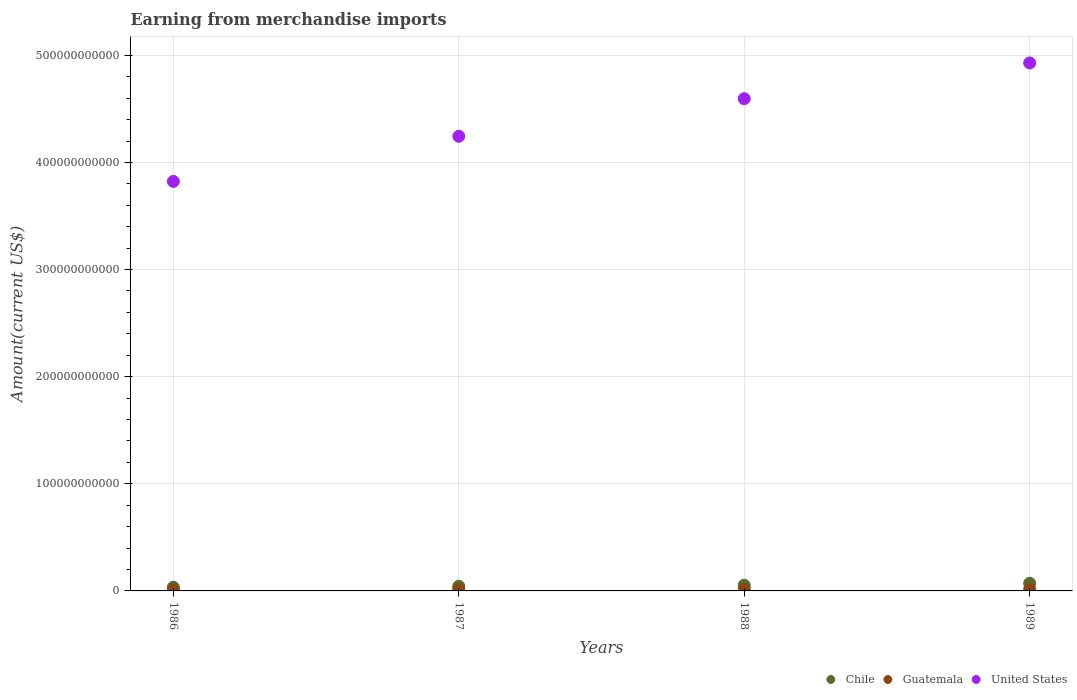How many different coloured dotlines are there?
Your answer should be compact. 3. What is the amount earned from merchandise imports in United States in 1986?
Ensure brevity in your answer.  3.82e+11. Across all years, what is the maximum amount earned from merchandise imports in Chile?
Ensure brevity in your answer.  7.14e+09. Across all years, what is the minimum amount earned from merchandise imports in Chile?
Offer a terse response. 3.44e+09. What is the total amount earned from merchandise imports in Chile in the graph?
Your answer should be compact. 2.03e+1. What is the difference between the amount earned from merchandise imports in Chile in 1986 and that in 1988?
Give a very brief answer. -1.86e+09. What is the difference between the amount earned from merchandise imports in Guatemala in 1986 and the amount earned from merchandise imports in United States in 1987?
Offer a very short reply. -4.23e+11. What is the average amount earned from merchandise imports in Chile per year?
Your answer should be compact. 5.07e+09. In the year 1986, what is the difference between the amount earned from merchandise imports in Chile and amount earned from merchandise imports in United States?
Make the answer very short. -3.79e+11. In how many years, is the amount earned from merchandise imports in Guatemala greater than 260000000000 US$?
Ensure brevity in your answer.  0. What is the ratio of the amount earned from merchandise imports in Guatemala in 1986 to that in 1989?
Make the answer very short. 0.58. Is the amount earned from merchandise imports in Guatemala in 1986 less than that in 1988?
Make the answer very short. Yes. Is the difference between the amount earned from merchandise imports in Chile in 1988 and 1989 greater than the difference between the amount earned from merchandise imports in United States in 1988 and 1989?
Your answer should be compact. Yes. What is the difference between the highest and the second highest amount earned from merchandise imports in Chile?
Your answer should be very brief. 1.85e+09. What is the difference between the highest and the lowest amount earned from merchandise imports in Chile?
Offer a terse response. 3.71e+09. In how many years, is the amount earned from merchandise imports in Chile greater than the average amount earned from merchandise imports in Chile taken over all years?
Keep it short and to the point. 2. Is the sum of the amount earned from merchandise imports in Chile in 1986 and 1989 greater than the maximum amount earned from merchandise imports in United States across all years?
Provide a short and direct response. No. Does the amount earned from merchandise imports in Guatemala monotonically increase over the years?
Offer a very short reply. Yes. How many dotlines are there?
Offer a terse response. 3. What is the difference between two consecutive major ticks on the Y-axis?
Ensure brevity in your answer.  1.00e+11. Are the values on the major ticks of Y-axis written in scientific E-notation?
Your answer should be compact. No. Does the graph contain grids?
Provide a succinct answer. Yes. Where does the legend appear in the graph?
Keep it short and to the point. Bottom right. How many legend labels are there?
Make the answer very short. 3. How are the legend labels stacked?
Your response must be concise. Horizontal. What is the title of the graph?
Make the answer very short. Earning from merchandise imports. Does "Isle of Man" appear as one of the legend labels in the graph?
Your response must be concise. No. What is the label or title of the X-axis?
Ensure brevity in your answer.  Years. What is the label or title of the Y-axis?
Offer a terse response. Amount(current US$). What is the Amount(current US$) in Chile in 1986?
Give a very brief answer. 3.44e+09. What is the Amount(current US$) of Guatemala in 1986?
Your answer should be very brief. 9.59e+08. What is the Amount(current US$) in United States in 1986?
Give a very brief answer. 3.82e+11. What is the Amount(current US$) in Chile in 1987?
Give a very brief answer. 4.40e+09. What is the Amount(current US$) in Guatemala in 1987?
Your answer should be very brief. 1.45e+09. What is the Amount(current US$) in United States in 1987?
Make the answer very short. 4.24e+11. What is the Amount(current US$) of Chile in 1988?
Your response must be concise. 5.29e+09. What is the Amount(current US$) in Guatemala in 1988?
Your answer should be compact. 1.56e+09. What is the Amount(current US$) in United States in 1988?
Your answer should be very brief. 4.60e+11. What is the Amount(current US$) in Chile in 1989?
Your answer should be compact. 7.14e+09. What is the Amount(current US$) of Guatemala in 1989?
Your answer should be very brief. 1.65e+09. What is the Amount(current US$) in United States in 1989?
Give a very brief answer. 4.93e+11. Across all years, what is the maximum Amount(current US$) in Chile?
Offer a very short reply. 7.14e+09. Across all years, what is the maximum Amount(current US$) in Guatemala?
Provide a short and direct response. 1.65e+09. Across all years, what is the maximum Amount(current US$) of United States?
Make the answer very short. 4.93e+11. Across all years, what is the minimum Amount(current US$) of Chile?
Make the answer very short. 3.44e+09. Across all years, what is the minimum Amount(current US$) of Guatemala?
Provide a succinct answer. 9.59e+08. Across all years, what is the minimum Amount(current US$) in United States?
Offer a very short reply. 3.82e+11. What is the total Amount(current US$) in Chile in the graph?
Provide a succinct answer. 2.03e+1. What is the total Amount(current US$) in Guatemala in the graph?
Give a very brief answer. 5.62e+09. What is the total Amount(current US$) in United States in the graph?
Offer a very short reply. 1.76e+12. What is the difference between the Amount(current US$) in Chile in 1986 and that in 1987?
Provide a short and direct response. -9.60e+08. What is the difference between the Amount(current US$) in Guatemala in 1986 and that in 1987?
Your answer should be very brief. -4.88e+08. What is the difference between the Amount(current US$) of United States in 1986 and that in 1987?
Your answer should be very brief. -4.21e+1. What is the difference between the Amount(current US$) of Chile in 1986 and that in 1988?
Give a very brief answer. -1.86e+09. What is the difference between the Amount(current US$) of Guatemala in 1986 and that in 1988?
Make the answer very short. -5.98e+08. What is the difference between the Amount(current US$) in United States in 1986 and that in 1988?
Keep it short and to the point. -7.72e+1. What is the difference between the Amount(current US$) in Chile in 1986 and that in 1989?
Your answer should be compact. -3.71e+09. What is the difference between the Amount(current US$) of Guatemala in 1986 and that in 1989?
Your answer should be compact. -6.95e+08. What is the difference between the Amount(current US$) in United States in 1986 and that in 1989?
Make the answer very short. -1.11e+11. What is the difference between the Amount(current US$) in Chile in 1987 and that in 1988?
Offer a terse response. -8.96e+08. What is the difference between the Amount(current US$) in Guatemala in 1987 and that in 1988?
Keep it short and to the point. -1.10e+08. What is the difference between the Amount(current US$) of United States in 1987 and that in 1988?
Offer a very short reply. -3.51e+1. What is the difference between the Amount(current US$) in Chile in 1987 and that in 1989?
Keep it short and to the point. -2.75e+09. What is the difference between the Amount(current US$) of Guatemala in 1987 and that in 1989?
Offer a very short reply. -2.07e+08. What is the difference between the Amount(current US$) in United States in 1987 and that in 1989?
Your answer should be very brief. -6.85e+1. What is the difference between the Amount(current US$) in Chile in 1988 and that in 1989?
Offer a very short reply. -1.85e+09. What is the difference between the Amount(current US$) in Guatemala in 1988 and that in 1989?
Give a very brief answer. -9.70e+07. What is the difference between the Amount(current US$) in United States in 1988 and that in 1989?
Your answer should be very brief. -3.34e+1. What is the difference between the Amount(current US$) of Chile in 1986 and the Amount(current US$) of Guatemala in 1987?
Offer a terse response. 1.99e+09. What is the difference between the Amount(current US$) in Chile in 1986 and the Amount(current US$) in United States in 1987?
Your answer should be very brief. -4.21e+11. What is the difference between the Amount(current US$) of Guatemala in 1986 and the Amount(current US$) of United States in 1987?
Make the answer very short. -4.23e+11. What is the difference between the Amount(current US$) in Chile in 1986 and the Amount(current US$) in Guatemala in 1988?
Make the answer very short. 1.88e+09. What is the difference between the Amount(current US$) in Chile in 1986 and the Amount(current US$) in United States in 1988?
Give a very brief answer. -4.56e+11. What is the difference between the Amount(current US$) of Guatemala in 1986 and the Amount(current US$) of United States in 1988?
Give a very brief answer. -4.59e+11. What is the difference between the Amount(current US$) of Chile in 1986 and the Amount(current US$) of Guatemala in 1989?
Provide a short and direct response. 1.78e+09. What is the difference between the Amount(current US$) in Chile in 1986 and the Amount(current US$) in United States in 1989?
Offer a very short reply. -4.89e+11. What is the difference between the Amount(current US$) in Guatemala in 1986 and the Amount(current US$) in United States in 1989?
Keep it short and to the point. -4.92e+11. What is the difference between the Amount(current US$) in Chile in 1987 and the Amount(current US$) in Guatemala in 1988?
Your response must be concise. 2.84e+09. What is the difference between the Amount(current US$) in Chile in 1987 and the Amount(current US$) in United States in 1988?
Your answer should be compact. -4.55e+11. What is the difference between the Amount(current US$) of Guatemala in 1987 and the Amount(current US$) of United States in 1988?
Make the answer very short. -4.58e+11. What is the difference between the Amount(current US$) in Chile in 1987 and the Amount(current US$) in Guatemala in 1989?
Provide a short and direct response. 2.74e+09. What is the difference between the Amount(current US$) of Chile in 1987 and the Amount(current US$) of United States in 1989?
Give a very brief answer. -4.89e+11. What is the difference between the Amount(current US$) of Guatemala in 1987 and the Amount(current US$) of United States in 1989?
Make the answer very short. -4.91e+11. What is the difference between the Amount(current US$) in Chile in 1988 and the Amount(current US$) in Guatemala in 1989?
Your answer should be compact. 3.64e+09. What is the difference between the Amount(current US$) of Chile in 1988 and the Amount(current US$) of United States in 1989?
Make the answer very short. -4.88e+11. What is the difference between the Amount(current US$) in Guatemala in 1988 and the Amount(current US$) in United States in 1989?
Give a very brief answer. -4.91e+11. What is the average Amount(current US$) of Chile per year?
Give a very brief answer. 5.07e+09. What is the average Amount(current US$) in Guatemala per year?
Your response must be concise. 1.40e+09. What is the average Amount(current US$) in United States per year?
Provide a short and direct response. 4.40e+11. In the year 1986, what is the difference between the Amount(current US$) of Chile and Amount(current US$) of Guatemala?
Your answer should be very brief. 2.48e+09. In the year 1986, what is the difference between the Amount(current US$) of Chile and Amount(current US$) of United States?
Your answer should be very brief. -3.79e+11. In the year 1986, what is the difference between the Amount(current US$) of Guatemala and Amount(current US$) of United States?
Your response must be concise. -3.81e+11. In the year 1987, what is the difference between the Amount(current US$) in Chile and Amount(current US$) in Guatemala?
Offer a very short reply. 2.95e+09. In the year 1987, what is the difference between the Amount(current US$) of Chile and Amount(current US$) of United States?
Give a very brief answer. -4.20e+11. In the year 1987, what is the difference between the Amount(current US$) of Guatemala and Amount(current US$) of United States?
Make the answer very short. -4.23e+11. In the year 1988, what is the difference between the Amount(current US$) in Chile and Amount(current US$) in Guatemala?
Provide a succinct answer. 3.74e+09. In the year 1988, what is the difference between the Amount(current US$) in Chile and Amount(current US$) in United States?
Your response must be concise. -4.54e+11. In the year 1988, what is the difference between the Amount(current US$) in Guatemala and Amount(current US$) in United States?
Give a very brief answer. -4.58e+11. In the year 1989, what is the difference between the Amount(current US$) in Chile and Amount(current US$) in Guatemala?
Make the answer very short. 5.49e+09. In the year 1989, what is the difference between the Amount(current US$) of Chile and Amount(current US$) of United States?
Provide a short and direct response. -4.86e+11. In the year 1989, what is the difference between the Amount(current US$) of Guatemala and Amount(current US$) of United States?
Make the answer very short. -4.91e+11. What is the ratio of the Amount(current US$) of Chile in 1986 to that in 1987?
Keep it short and to the point. 0.78. What is the ratio of the Amount(current US$) of Guatemala in 1986 to that in 1987?
Give a very brief answer. 0.66. What is the ratio of the Amount(current US$) of United States in 1986 to that in 1987?
Your response must be concise. 0.9. What is the ratio of the Amount(current US$) of Chile in 1986 to that in 1988?
Your response must be concise. 0.65. What is the ratio of the Amount(current US$) in Guatemala in 1986 to that in 1988?
Your answer should be very brief. 0.62. What is the ratio of the Amount(current US$) in United States in 1986 to that in 1988?
Provide a short and direct response. 0.83. What is the ratio of the Amount(current US$) of Chile in 1986 to that in 1989?
Give a very brief answer. 0.48. What is the ratio of the Amount(current US$) in Guatemala in 1986 to that in 1989?
Offer a terse response. 0.58. What is the ratio of the Amount(current US$) in United States in 1986 to that in 1989?
Your answer should be very brief. 0.78. What is the ratio of the Amount(current US$) of Chile in 1987 to that in 1988?
Your response must be concise. 0.83. What is the ratio of the Amount(current US$) in Guatemala in 1987 to that in 1988?
Provide a succinct answer. 0.93. What is the ratio of the Amount(current US$) of United States in 1987 to that in 1988?
Give a very brief answer. 0.92. What is the ratio of the Amount(current US$) of Chile in 1987 to that in 1989?
Ensure brevity in your answer.  0.62. What is the ratio of the Amount(current US$) in Guatemala in 1987 to that in 1989?
Keep it short and to the point. 0.87. What is the ratio of the Amount(current US$) of United States in 1987 to that in 1989?
Make the answer very short. 0.86. What is the ratio of the Amount(current US$) of Chile in 1988 to that in 1989?
Make the answer very short. 0.74. What is the ratio of the Amount(current US$) of Guatemala in 1988 to that in 1989?
Offer a very short reply. 0.94. What is the ratio of the Amount(current US$) in United States in 1988 to that in 1989?
Offer a very short reply. 0.93. What is the difference between the highest and the second highest Amount(current US$) in Chile?
Give a very brief answer. 1.85e+09. What is the difference between the highest and the second highest Amount(current US$) of Guatemala?
Provide a succinct answer. 9.70e+07. What is the difference between the highest and the second highest Amount(current US$) in United States?
Make the answer very short. 3.34e+1. What is the difference between the highest and the lowest Amount(current US$) in Chile?
Offer a terse response. 3.71e+09. What is the difference between the highest and the lowest Amount(current US$) of Guatemala?
Provide a short and direct response. 6.95e+08. What is the difference between the highest and the lowest Amount(current US$) of United States?
Ensure brevity in your answer.  1.11e+11. 